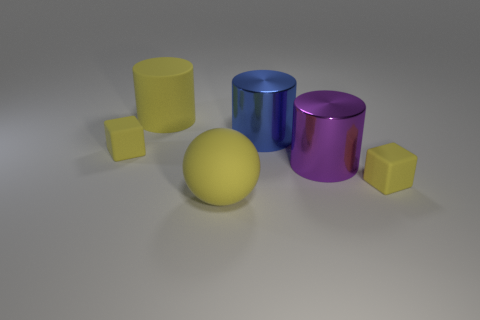How many objects are there in the image in total? There are five objects in total; three cylinders and two cubes. 